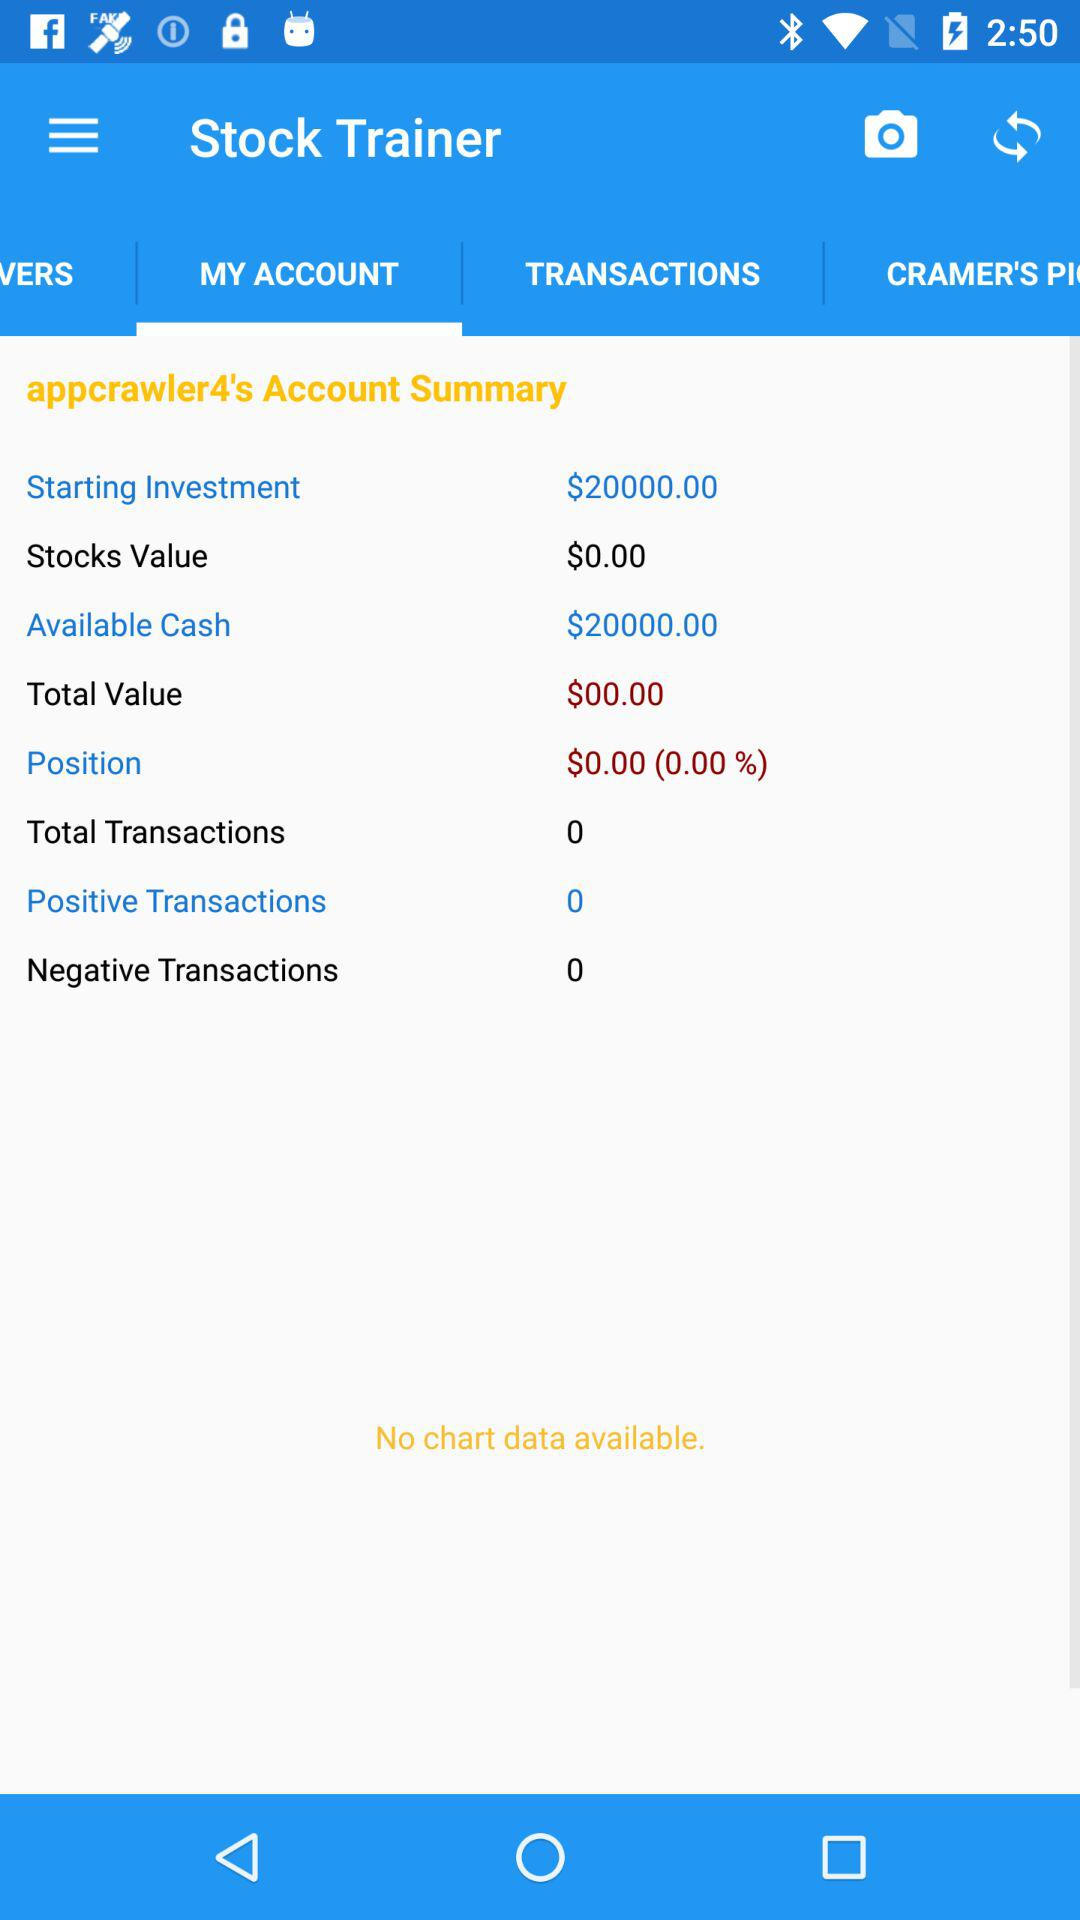How many negative transactions are there? There are 0 negative transactions. 